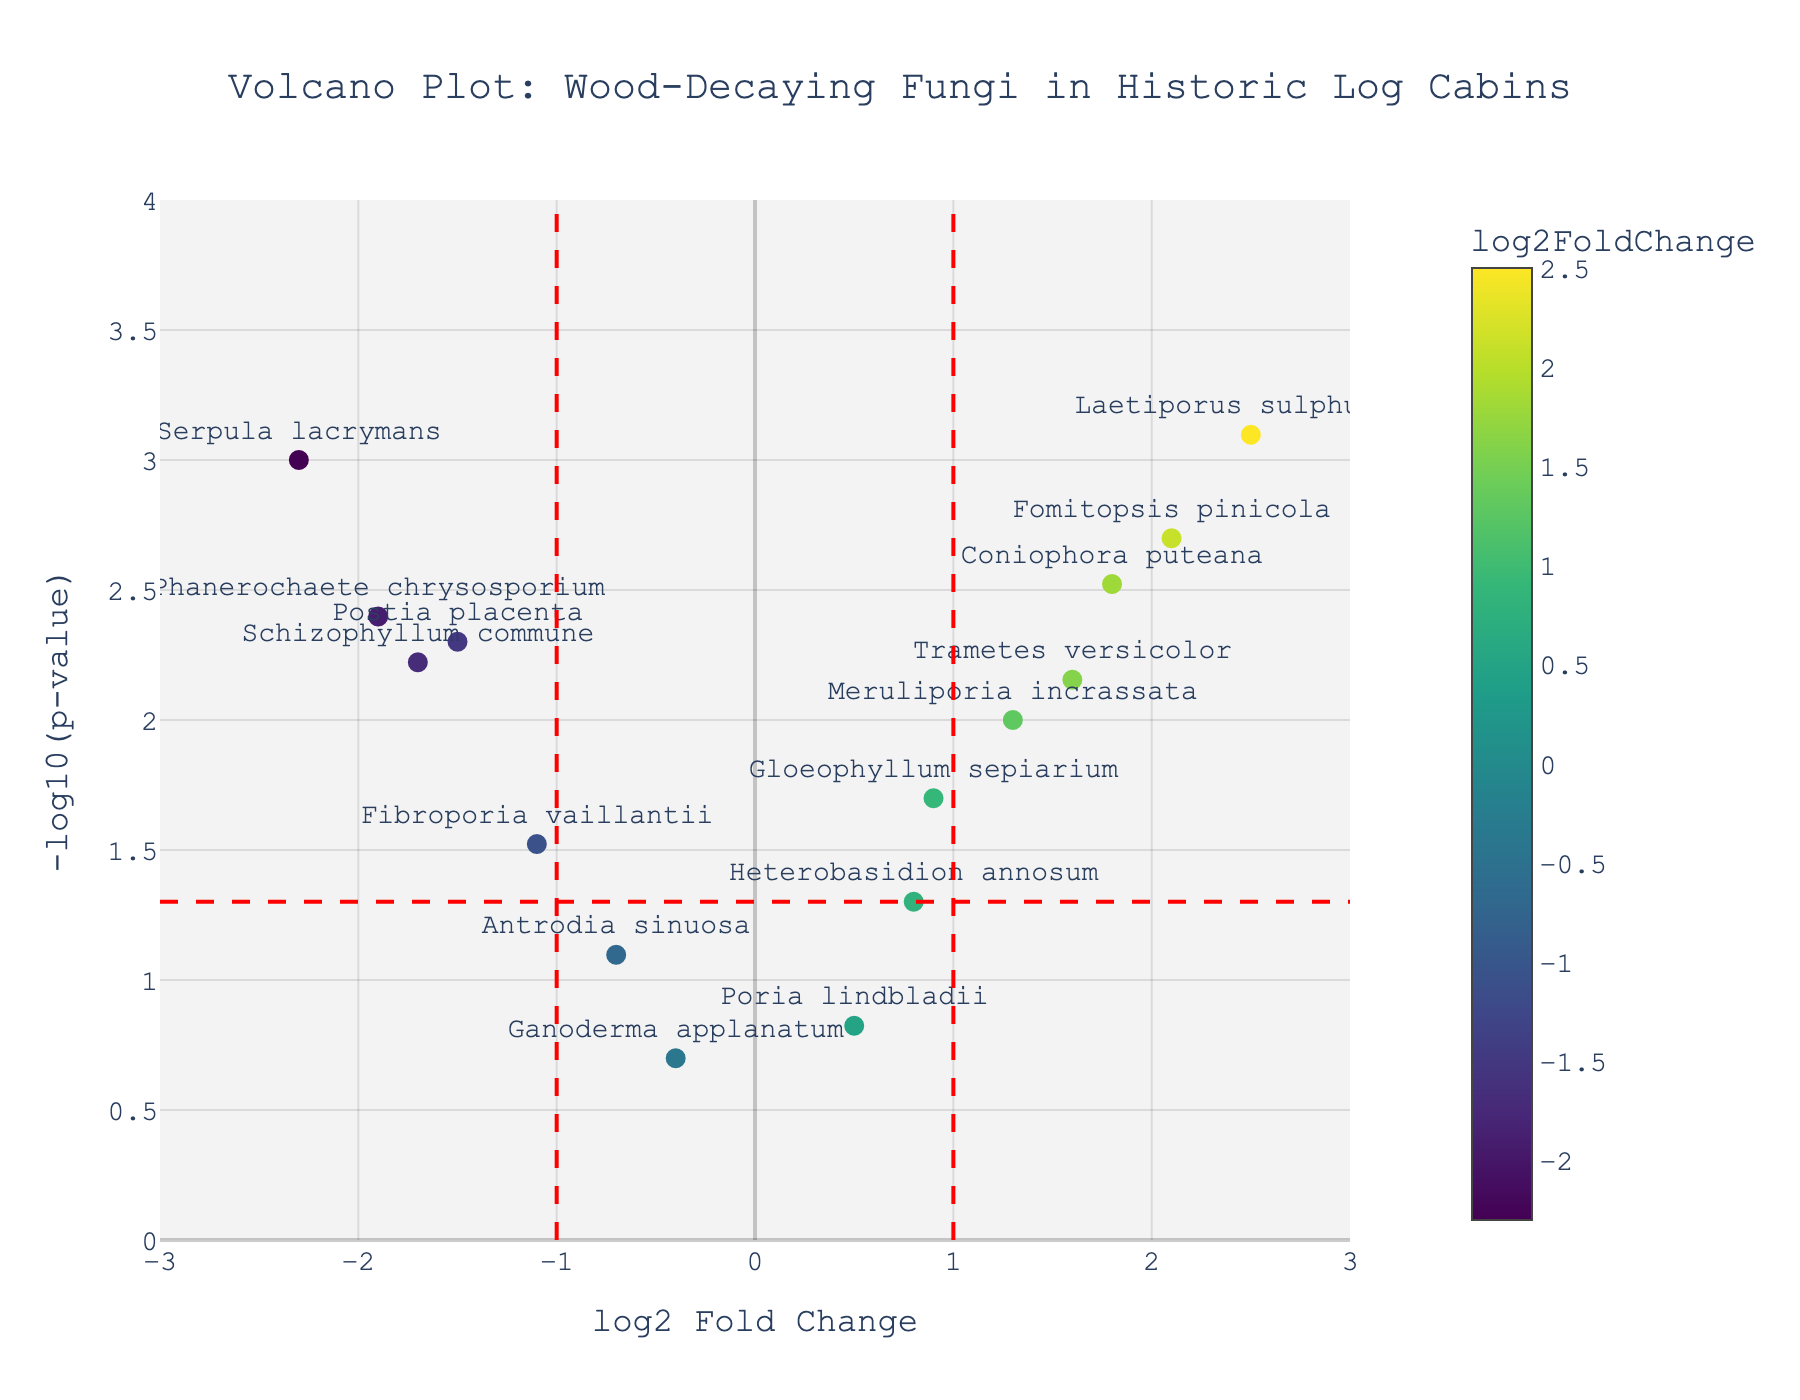How many fungi species have a log2 fold change greater than 0? The fungi species with a log2 fold change greater than 0 will be to the right of the vertical line at log2 fold change = 0. Counting those points, we get Coniophora puteana, Gloeophyllum sepiarium, Fomitopsis pinicola, Meruliporia incrassata, Poria lindbladii, Laetiporus sulphureus, Heterobasidion annosum, and Trametes versicolor, which is 8 species.
Answer: 8 Which fungus has the highest log2 fold change? The fungus with the highest log2 fold change will be the farthest to the right on the X-axis. Laetiporus sulphureus has the highest log2 fold change.
Answer: Laetiporus sulphureus What is the p-value threshold indicated by the horizontal red dashed line? The horizontal red dashed line indicates the threshold at -log10(p-value) = 1.3. To find the p-value threshold, we need to calculate 10^(-1.3). This gives approximately 0.05.
Answer: 0.05 Which fungi are significantly upregulated (log2 fold change > 1 and p-value < 0.05)? To find significantly upregulated fungi, we look for points to the right of log2 fold change = 1 and above the horizontal line at -log10(p-value) = 1.3. These fungi are Coniophora puteana, Fomitopsis pinicola, Laetiporus sulphureus, and Trametes versicolor.
Answer: Coniophora puteana, Fomitopsis pinicola, Laetiporus sulphureus, Trametes versicolor Which fungus has the smallest p-value? The smallest p-value corresponds to the highest -log10(p-value). Laetiporus sulphureus is at the highest point on the y-axis.
Answer: Laetiporus sulphureus How many fungi have log2 fold changes less than -1? To find fungi with log2 fold changes less than -1, we look to the left of the vertical dashed line at log2 fold change = -1. The fungi are Serpula lacrymans, Postia placenta, Phanerochaete chrysosporium, and Schizophyllum commune, which is 4 species.
Answer: 4 What are the log2 fold change values of the fungi with p-values below 0.01? Fungi with p-values below 0.01 will be above the horizontal dashed line at -log10(p-value) = 2. The fungi are Serpula lacrymans (-2.3), Coniophora puteana (1.8), Fomitopsis pinicola (2.1), Laetiporus sulphureus (2.5), Phanerochaete chrysosporium (-1.9), and Schizophyllum commune (-1.7).
Answer: -2.3, 1.8, 2.1, 2.5, -1.9, -1.7 